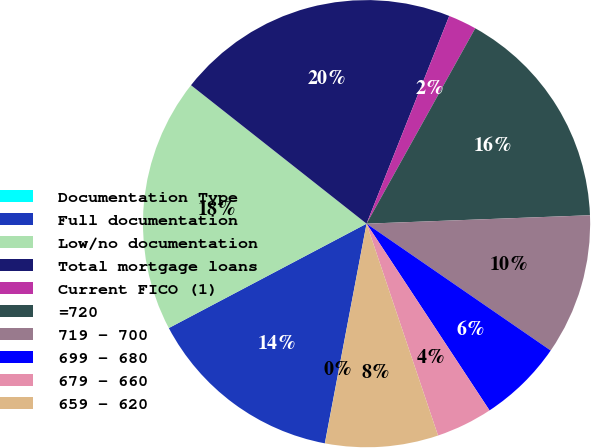<chart> <loc_0><loc_0><loc_500><loc_500><pie_chart><fcel>Documentation Type<fcel>Full documentation<fcel>Low/no documentation<fcel>Total mortgage loans<fcel>Current FICO (1)<fcel>=720<fcel>719 - 700<fcel>699 - 680<fcel>679 - 660<fcel>659 - 620<nl><fcel>0.01%<fcel>14.28%<fcel>18.36%<fcel>20.4%<fcel>2.05%<fcel>16.32%<fcel>10.2%<fcel>6.13%<fcel>4.09%<fcel>8.16%<nl></chart> 